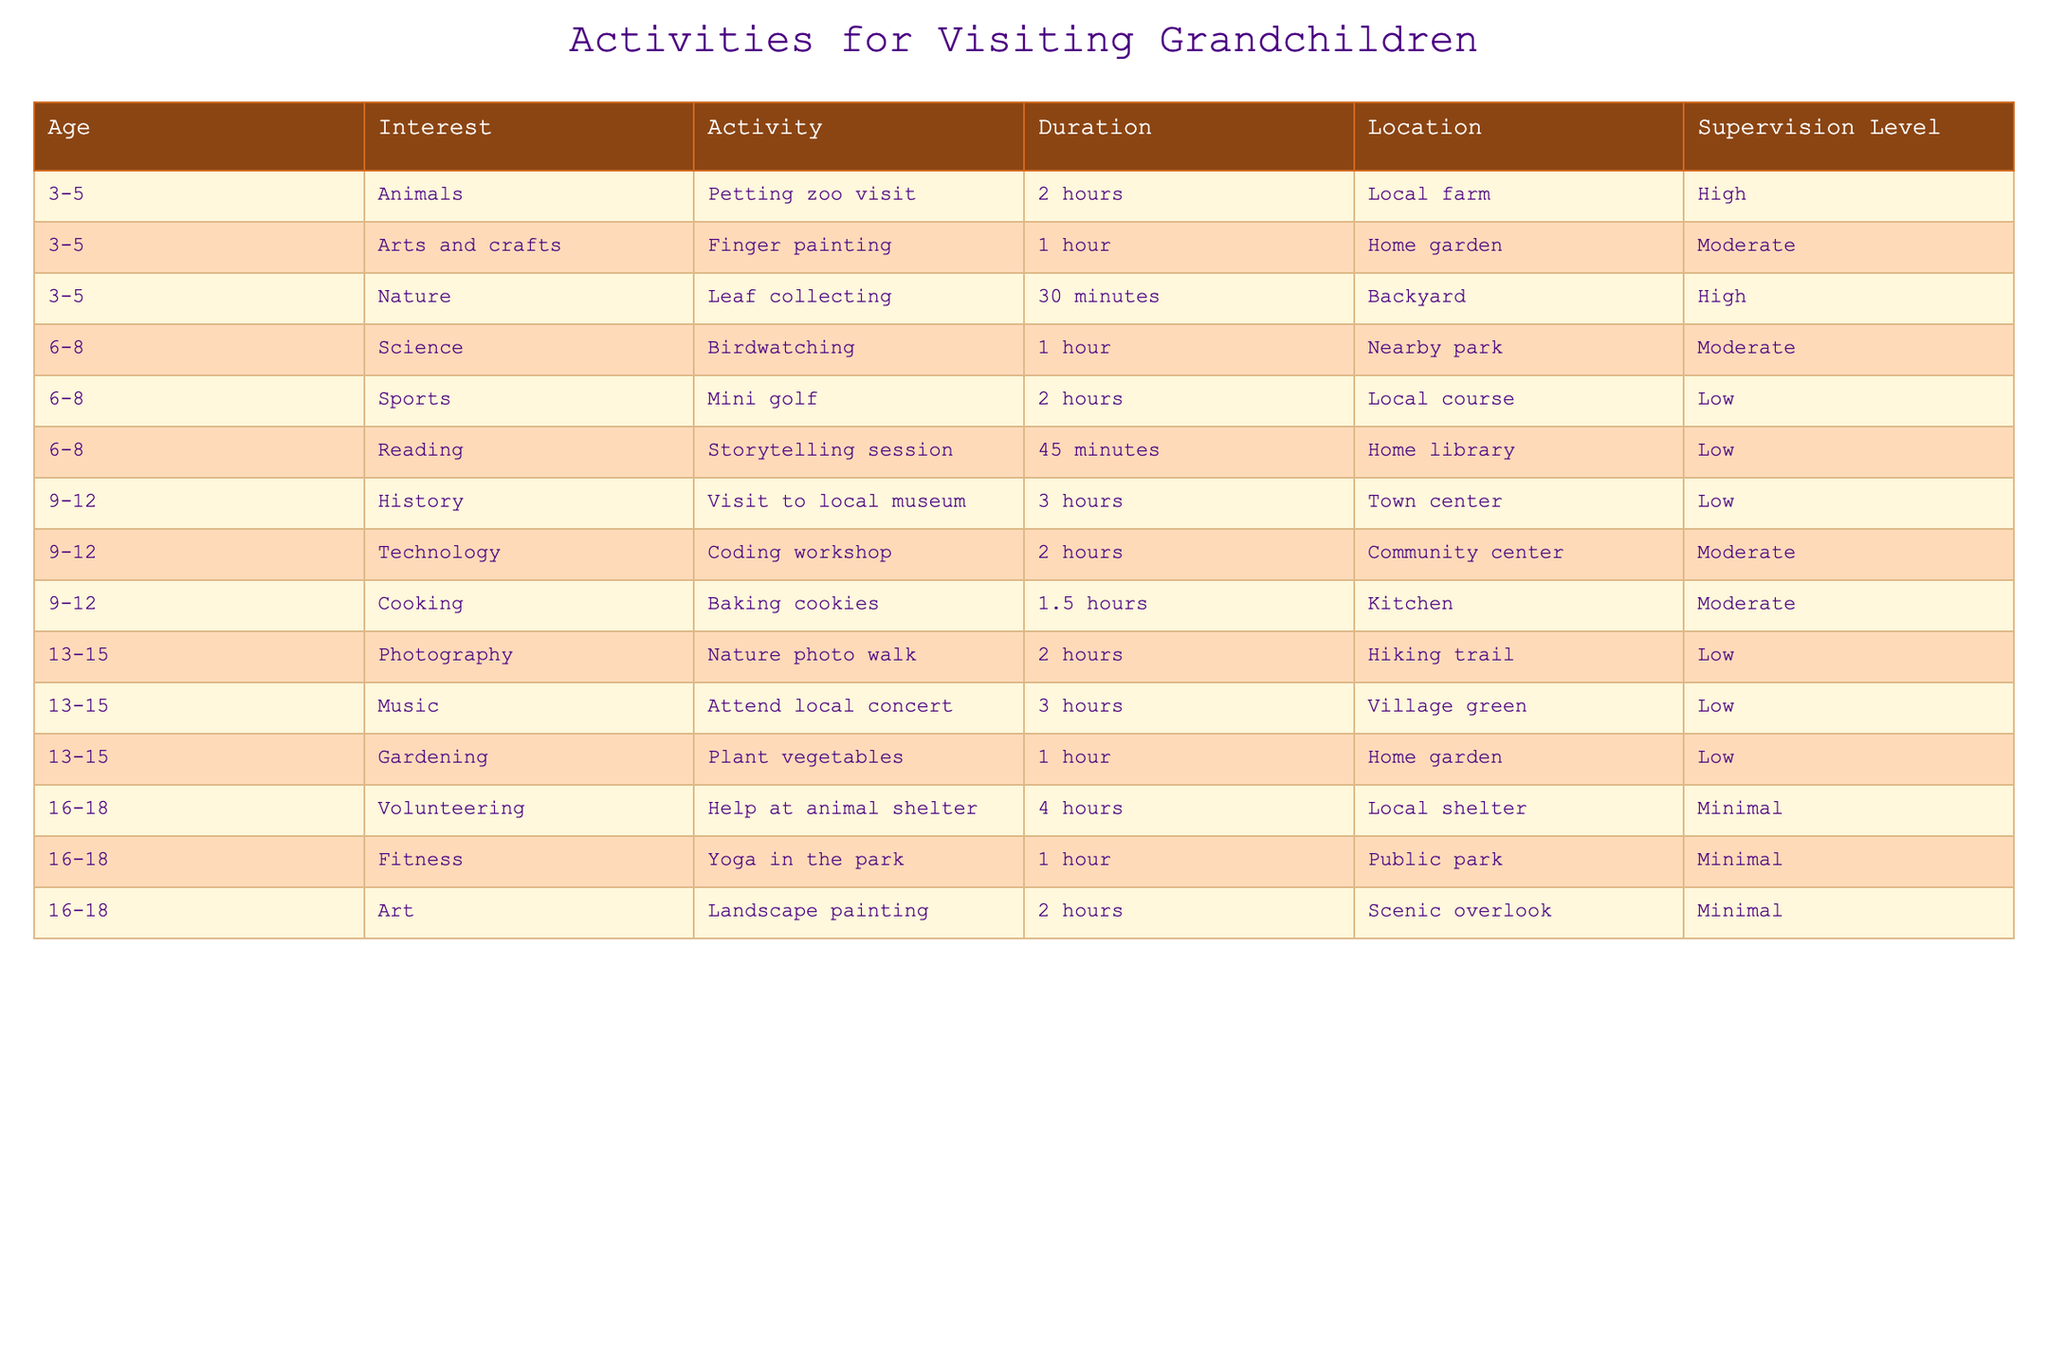What activity is suitable for 3-5-year-olds interested in nature? The table shows that for 3-5-year-olds with an interest in nature, the suitable activity is "Leaf collecting," which takes 30 minutes and has a high supervision level.
Answer: Leaf collecting How long does the mini golf activity last for children aged 6-8? According to the table, mini golf for children in the 6-8 age group lasts for 2 hours.
Answer: 2 hours Is "Coding workshop" an activity for children aged 9-12? The table lists "Coding workshop" under the age group of 9-12, which confirms that this activity is indeed suitable for them.
Answer: Yes What is the supervision level required for "Baking cookies"? The table indicates that "Baking cookies" has a moderate supervision level, meaning it requires some oversight but not intensive supervision.
Answer: Moderate Which activity has the longest duration for teenagers aged 16-18? By examining the table, the longest duration activity for teenagers aged 16-18 is "Help at animal shelter," lasting 4 hours.
Answer: Help at animal shelter Are there any activities for children aged 3-5 focused on arts and crafts? The table shows that "Finger painting" is an arts and crafts activity for 3-5-year-olds, confirming that such activities are available for this age group.
Answer: Yes What is the average duration of activities listed for children aged 6-8? To find the average, we first note the durations: mini golf (2 hours), birdwatching (1 hour), and storytelling session (45 minutes, which is 0.75 hours). Adding these gives 2 + 1 + 0.75 = 3.75 hours. There are 3 activities, so the average is 3.75 / 3 = 1.25 hours.
Answer: 1.25 hours How many activities have a minimal supervision level for ages 16-18? The table lists three activities for ages 16-18: "Help at animal shelter," "Yoga in the park," and "Landscape painting." All three have a minimal supervision level, confirming there are three such activities.
Answer: 3 activities Is there an activity suitable for all age groups listed in the table? Upon reviewing the table, each age group has specific activities categorized by age, with no single activity spanning all age groups, confirming that no activities are suitable for all age groups.
Answer: No 